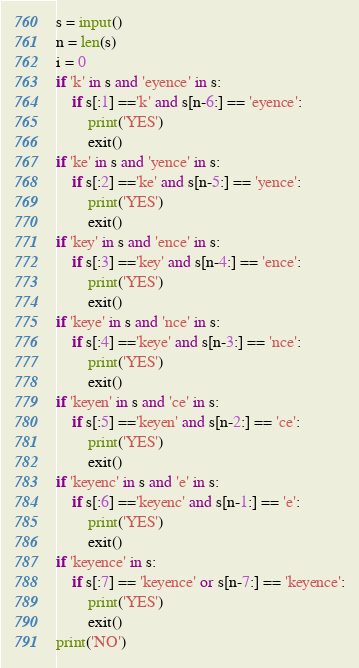Convert code to text. <code><loc_0><loc_0><loc_500><loc_500><_Python_>s = input()
n = len(s)
i = 0
if 'k' in s and 'eyence' in s:
    if s[:1] =='k' and s[n-6:] == 'eyence':
        print('YES')
        exit()
if 'ke' in s and 'yence' in s:
    if s[:2] =='ke' and s[n-5:] == 'yence':
        print('YES')
        exit()
if 'key' in s and 'ence' in s:
    if s[:3] =='key' and s[n-4:] == 'ence':
        print('YES')
        exit()
if 'keye' in s and 'nce' in s:
    if s[:4] =='keye' and s[n-3:] == 'nce':
        print('YES')
        exit()
if 'keyen' in s and 'ce' in s:
    if s[:5] =='keyen' and s[n-2:] == 'ce':
        print('YES')
        exit()
if 'keyenc' in s and 'e' in s:
    if s[:6] =='keyenc' and s[n-1:] == 'e':
        print('YES')
        exit()
if 'keyence' in s:
    if s[:7] == 'keyence' or s[n-7:] == 'keyence':
        print('YES')
        exit()
print('NO')</code> 